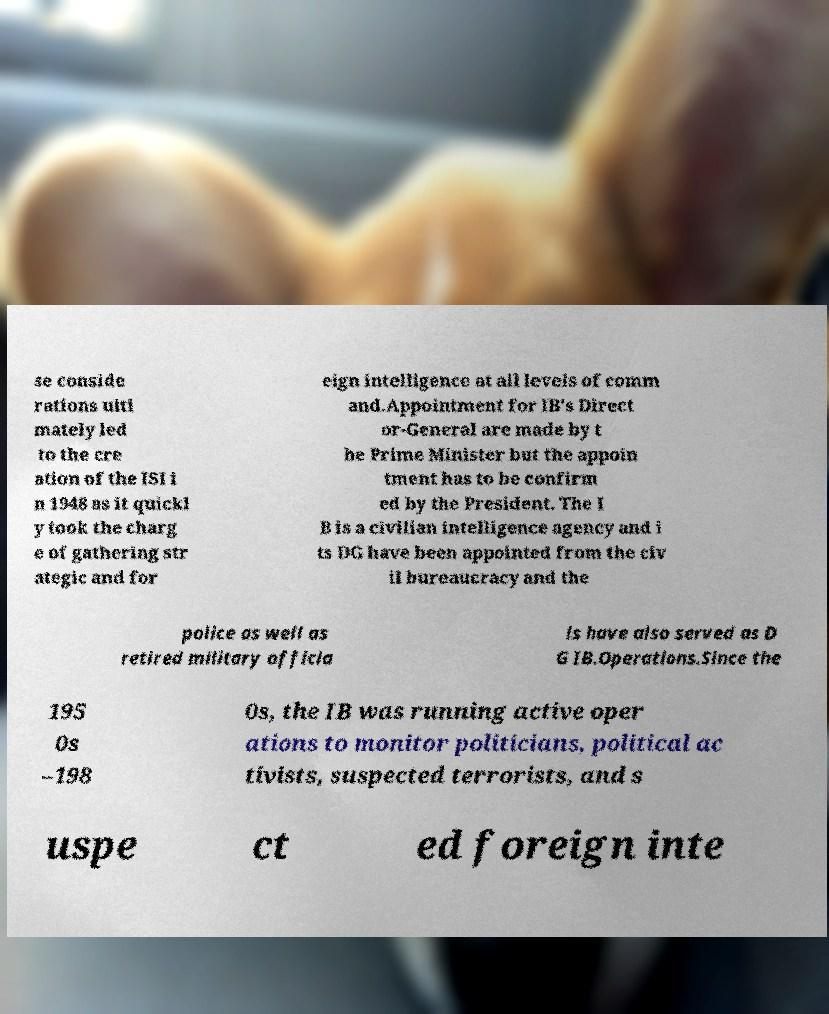Can you accurately transcribe the text from the provided image for me? se conside rations ulti mately led to the cre ation of the ISI i n 1948 as it quickl y took the charg e of gathering str ategic and for eign intelligence at all levels of comm and.Appointment for IB's Direct or-General are made by t he Prime Minister but the appoin tment has to be confirm ed by the President. The I B is a civilian intelligence agency and i ts DG have been appointed from the civ il bureaucracy and the police as well as retired military officia ls have also served as D G IB.Operations.Since the 195 0s –198 0s, the IB was running active oper ations to monitor politicians, political ac tivists, suspected terrorists, and s uspe ct ed foreign inte 